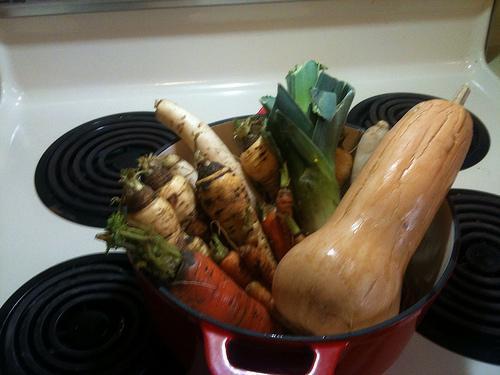How many different types of vegetables are in this pot?
Give a very brief answer. 4. 